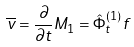<formula> <loc_0><loc_0><loc_500><loc_500>\overline { v } = \frac { \partial } { \partial t } M _ { 1 } = \hat { \Phi } _ { t } ^ { ( 1 ) } f</formula> 